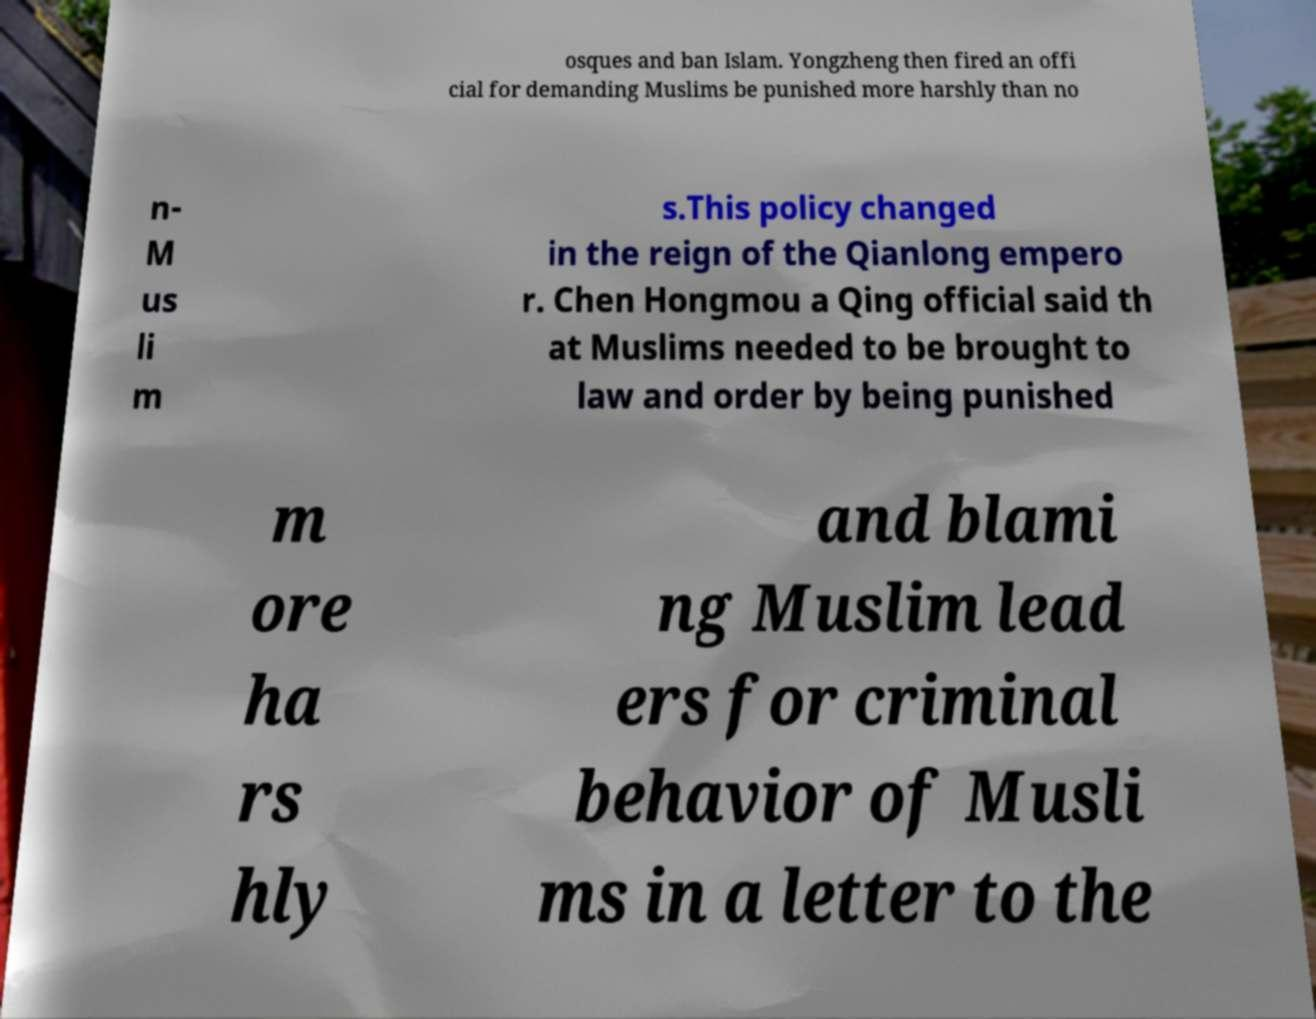Please identify and transcribe the text found in this image. osques and ban Islam. Yongzheng then fired an offi cial for demanding Muslims be punished more harshly than no n- M us li m s.This policy changed in the reign of the Qianlong empero r. Chen Hongmou a Qing official said th at Muslims needed to be brought to law and order by being punished m ore ha rs hly and blami ng Muslim lead ers for criminal behavior of Musli ms in a letter to the 